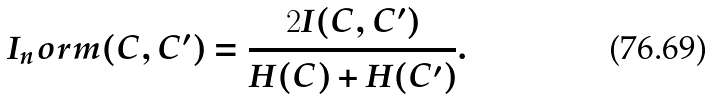Convert formula to latex. <formula><loc_0><loc_0><loc_500><loc_500>I _ { n } o r m ( C , C ^ { \prime } ) = \frac { 2 I ( C , C ^ { \prime } ) } { H ( C ) + H ( C ^ { \prime } ) } .</formula> 